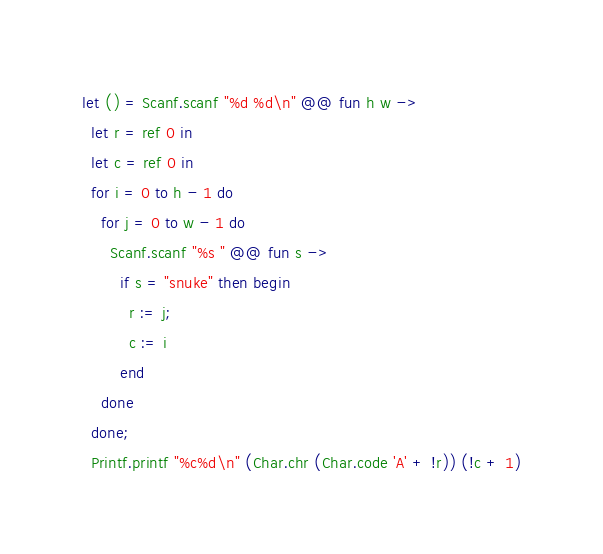<code> <loc_0><loc_0><loc_500><loc_500><_OCaml_>let () = Scanf.scanf "%d %d\n" @@ fun h w ->
  let r = ref 0 in
  let c = ref 0 in
  for i = 0 to h - 1 do
    for j = 0 to w - 1 do
      Scanf.scanf "%s " @@ fun s ->
        if s = "snuke" then begin
          r := j;
          c := i
        end
    done
  done;
  Printf.printf "%c%d\n" (Char.chr (Char.code 'A' + !r)) (!c + 1)
</code> 